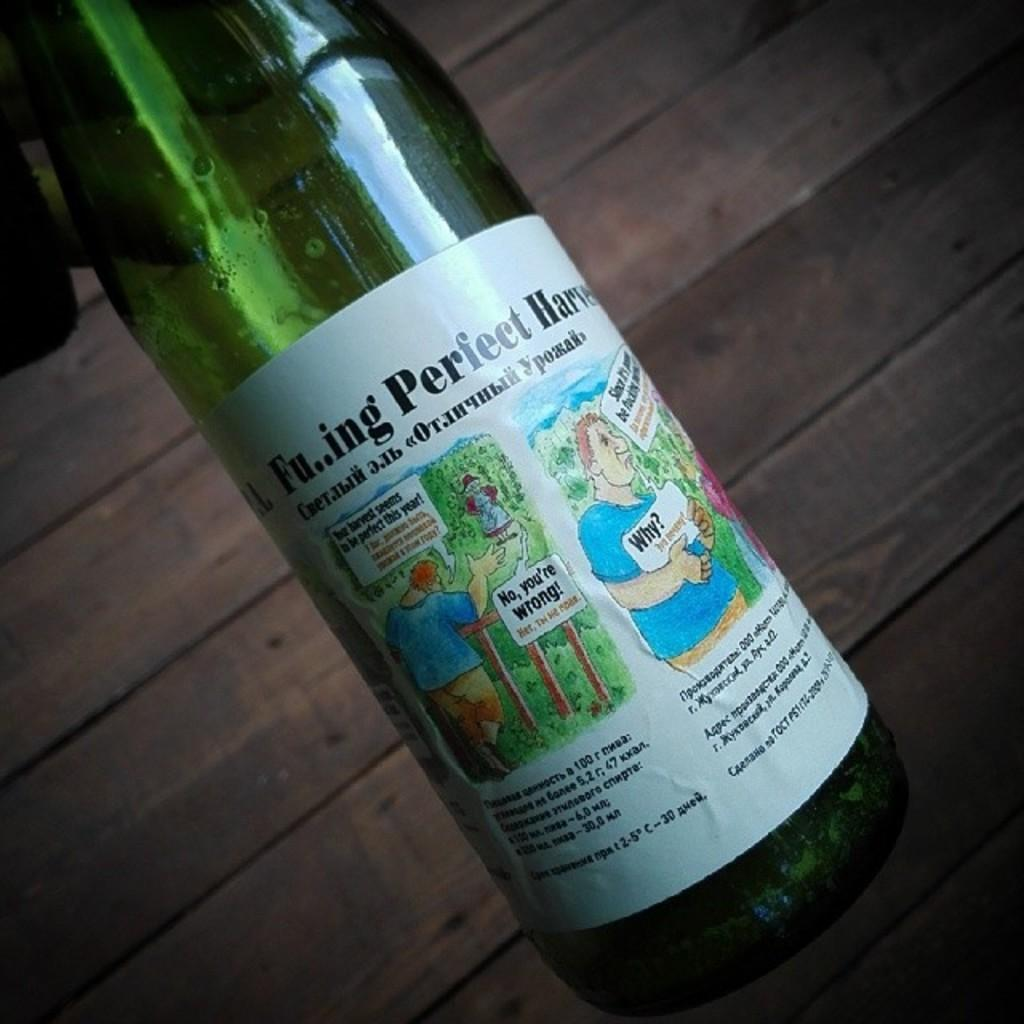Provide a one-sentence caption for the provided image. A beverage bottle has a cartoon man holding a sign that says Why? on it. 